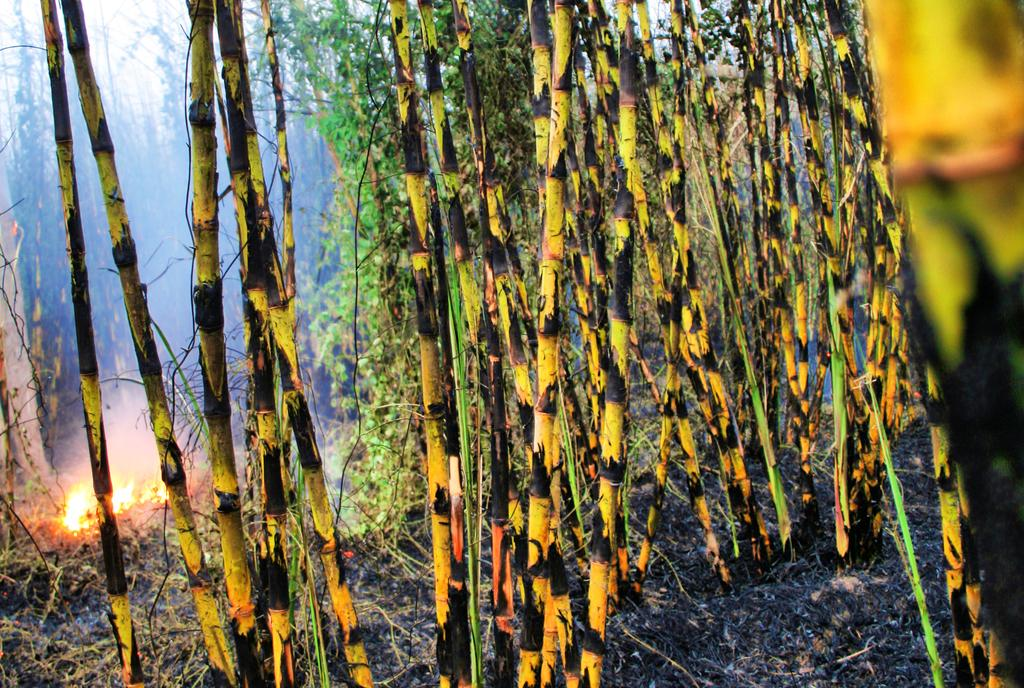What type of vegetation can be seen in the image? There are trees in the image. What is happening on the grass in the image? There is fire on the grass in the image. What type of veil can be seen covering the trees in the image? There is no veil present in the image; the trees are not covered. What type of music can be heard playing in the background of the image? There is no music present in the image; it is a still image without any sound. 